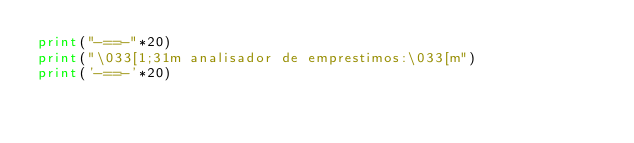<code> <loc_0><loc_0><loc_500><loc_500><_Python_>print("-==-"*20)
print("\033[1;31m analisador de emprestimos:\033[m")
print('-==-'*20)
</code> 